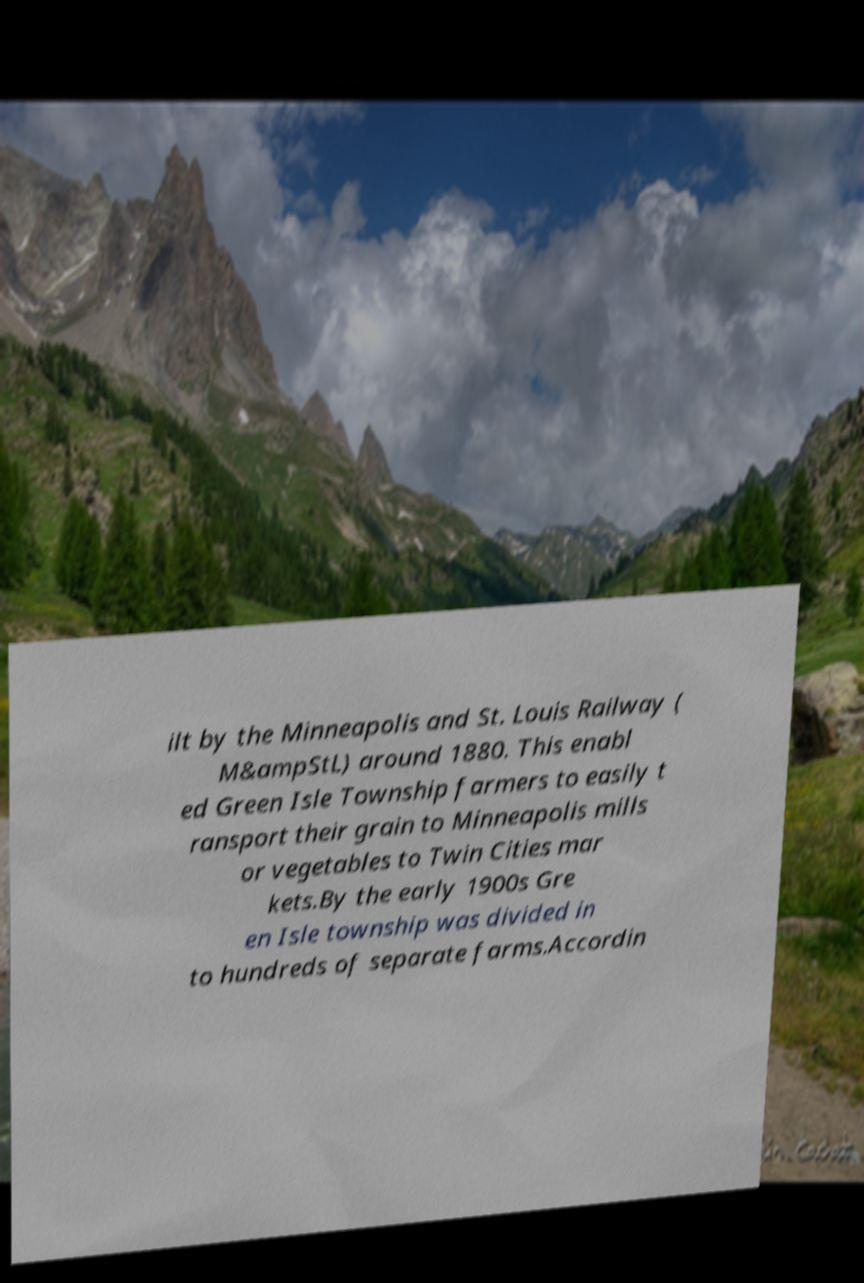What messages or text are displayed in this image? I need them in a readable, typed format. ilt by the Minneapolis and St. Louis Railway ( M&ampStL) around 1880. This enabl ed Green Isle Township farmers to easily t ransport their grain to Minneapolis mills or vegetables to Twin Cities mar kets.By the early 1900s Gre en Isle township was divided in to hundreds of separate farms.Accordin 